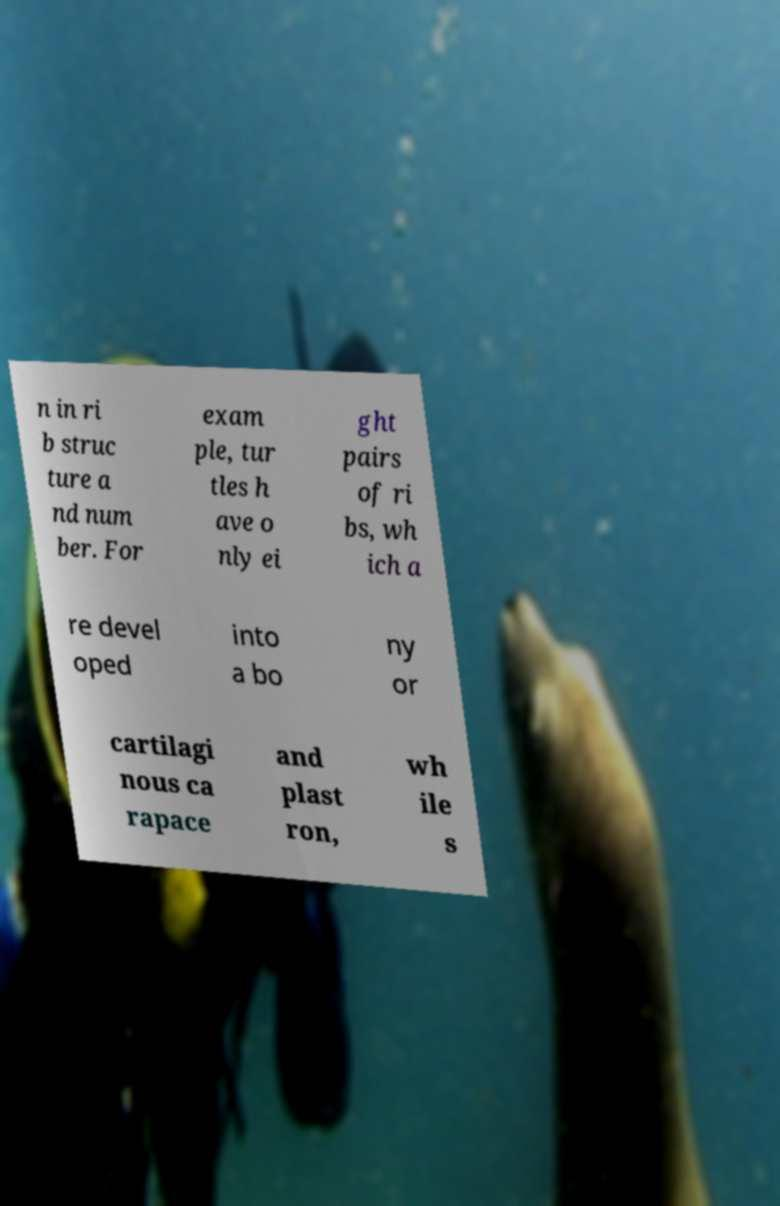For documentation purposes, I need the text within this image transcribed. Could you provide that? n in ri b struc ture a nd num ber. For exam ple, tur tles h ave o nly ei ght pairs of ri bs, wh ich a re devel oped into a bo ny or cartilagi nous ca rapace and plast ron, wh ile s 